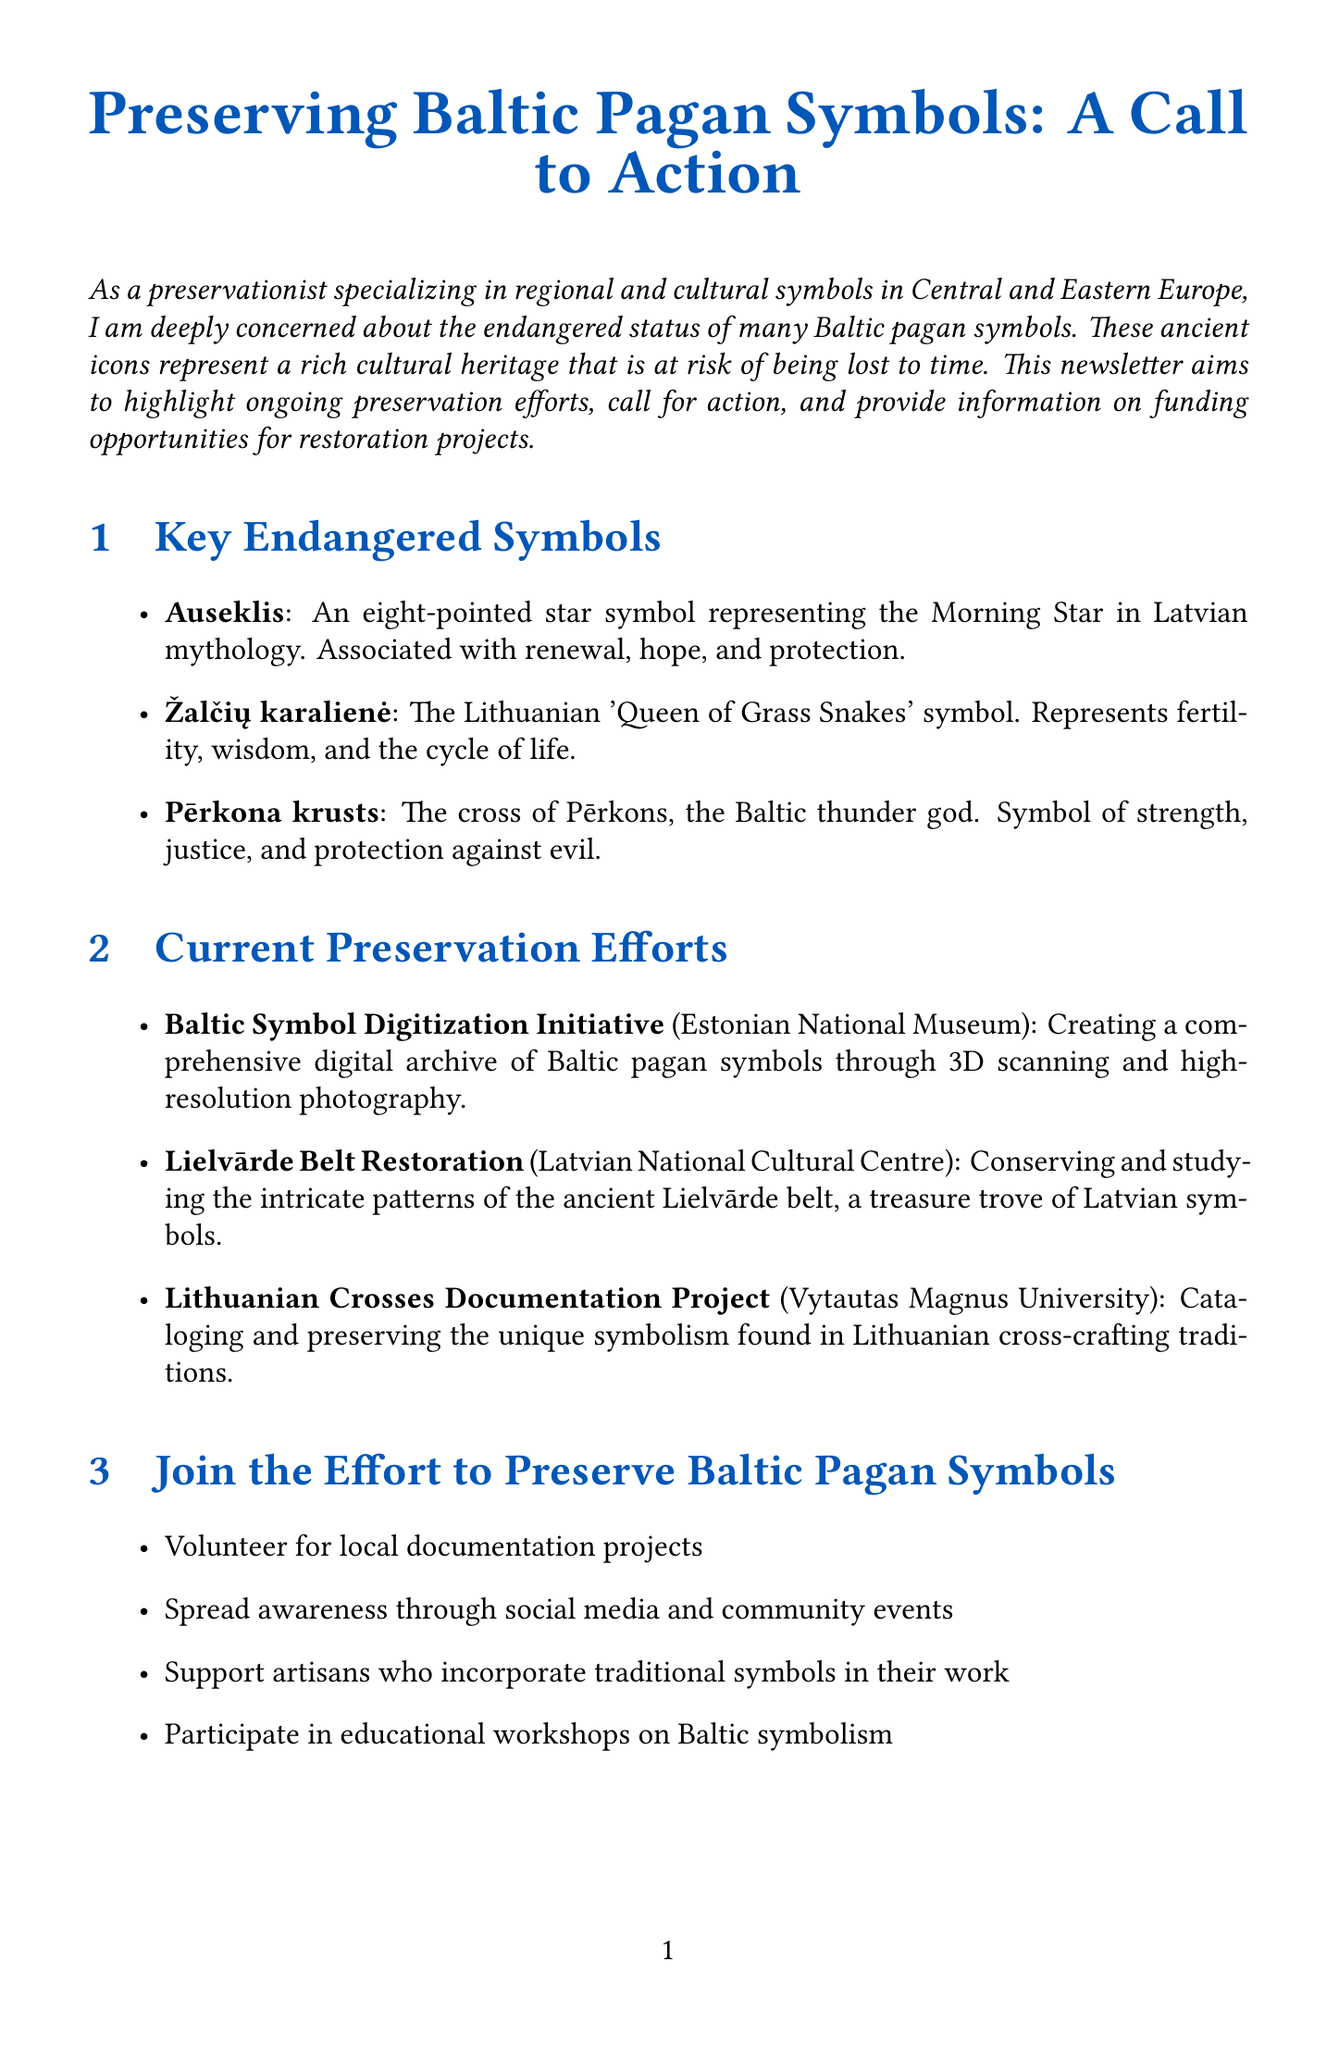What is the title of the newsletter? The title summarizes the main focus of the newsletter, which is on the preservation of Baltic pagan symbols.
Answer: Preserving Baltic Pagan Symbols: A Call to Action What symbolizes the Morning Star in Latvian mythology? This question seeks to identify one of the endangered symbols mentioned in the document.
Answer: Auseklis Which organization is behind the Baltic Symbol Digitization Initiative? This asks for the name of the organization that is undertaking a specific preservation project.
Answer: Estonian National Museum What is the deadline for the Baltic-Nordic Heritage Fund? The question inquires about a specific date related to funding opportunities mentioned in the newsletter.
Answer: September 30, 2023 What are two actions suggested for supporting preservation efforts? This question requires the reader to synthesize information from the call to action section.
Answer: Volunteer for local documentation projects, Spread awareness through social media and community events What does the Žalčių karalienė represent? This question requires recall of the significance of a specific endangered symbol mentioned in the document.
Answer: Fertility, wisdom, and the cycle of life What type of funding does the European Heritage Awards support? This asks for the nature of projects that the funding opportunity aims to recognize and support.
Answer: Outstanding heritage achievements What is the main focus of the newsletter? This question asks for a general summary of the document's purpose.
Answer: To highlight preservation efforts, call for action, and provide funding information 